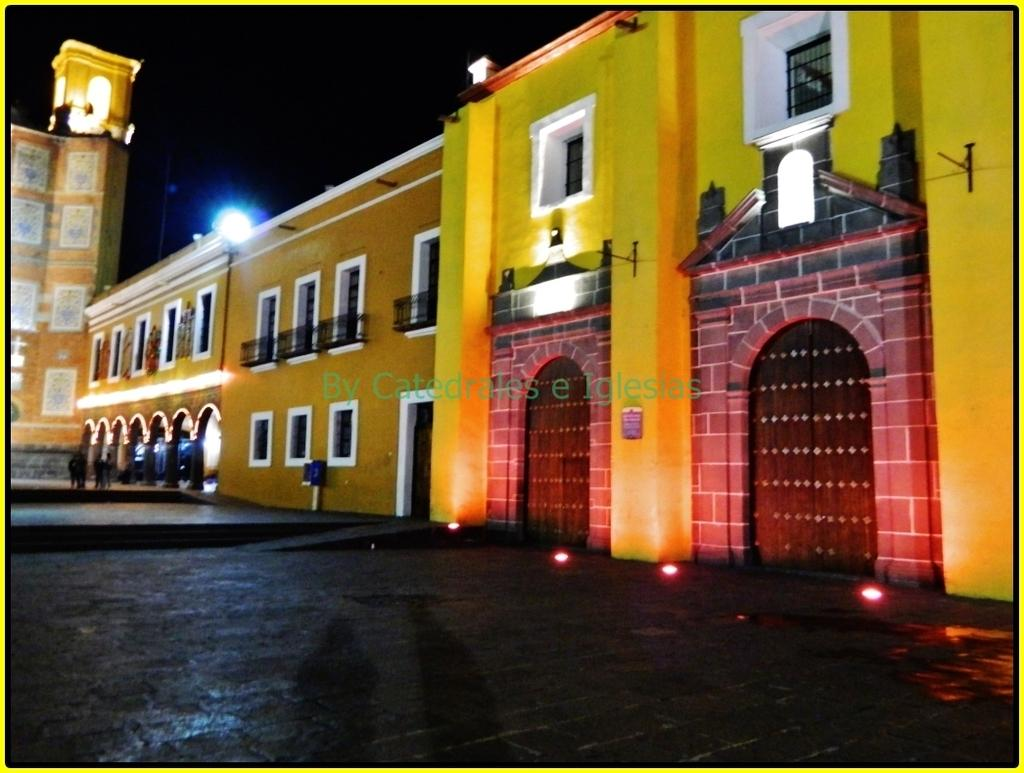What type of structures can be seen in the image? There are buildings in the image. What are the people in the image doing? People are walking in the image. What can be seen illuminating the scene in the image? There are lights visible in the image. What is the appearance of the sky in the background of the image? The sky in the background of the image is dark. Can you see any nuts being cracked by ants in the image? There are no nuts or ants present in the image. Is there a boat visible in the image? There is no boat present in the image. 